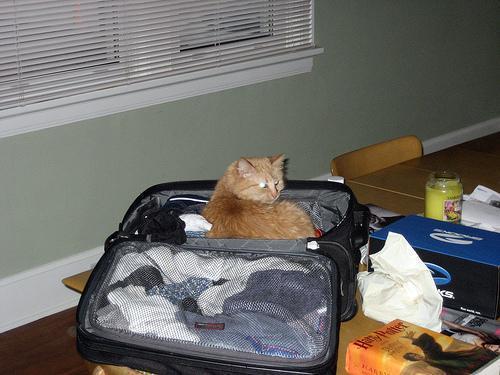How many cats are there?
Give a very brief answer. 1. 